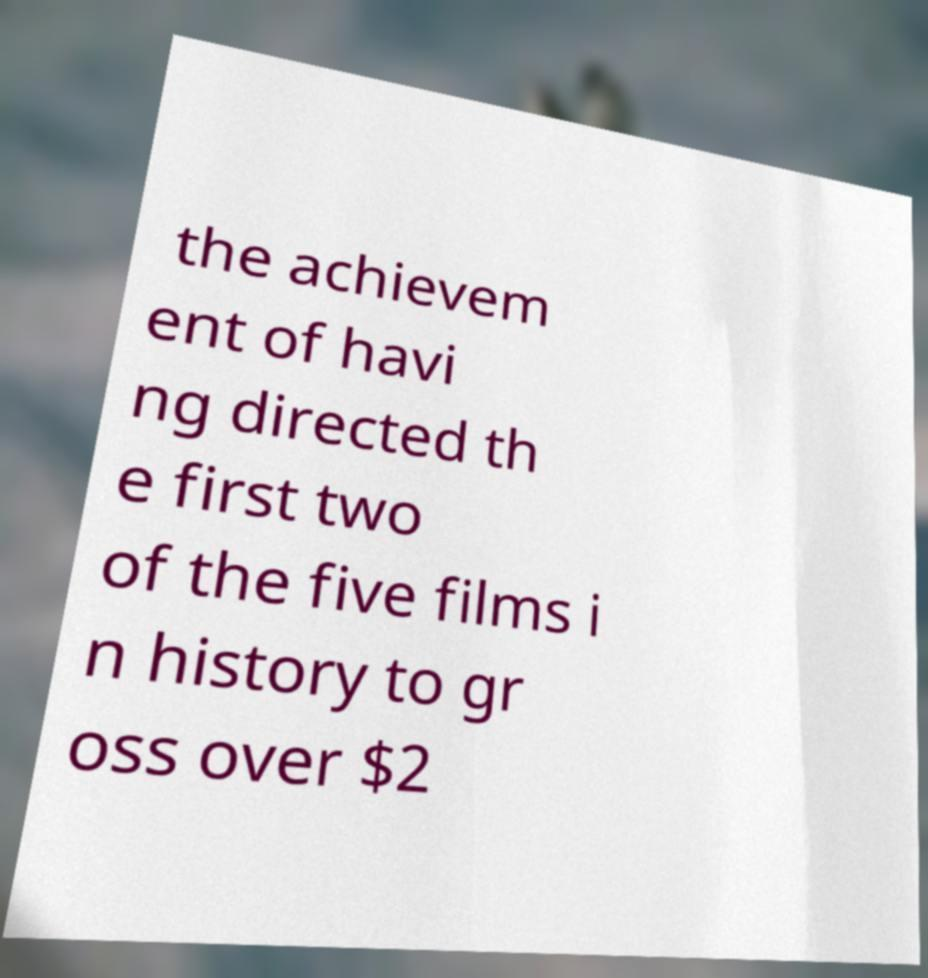There's text embedded in this image that I need extracted. Can you transcribe it verbatim? the achievem ent of havi ng directed th e first two of the five films i n history to gr oss over $2 